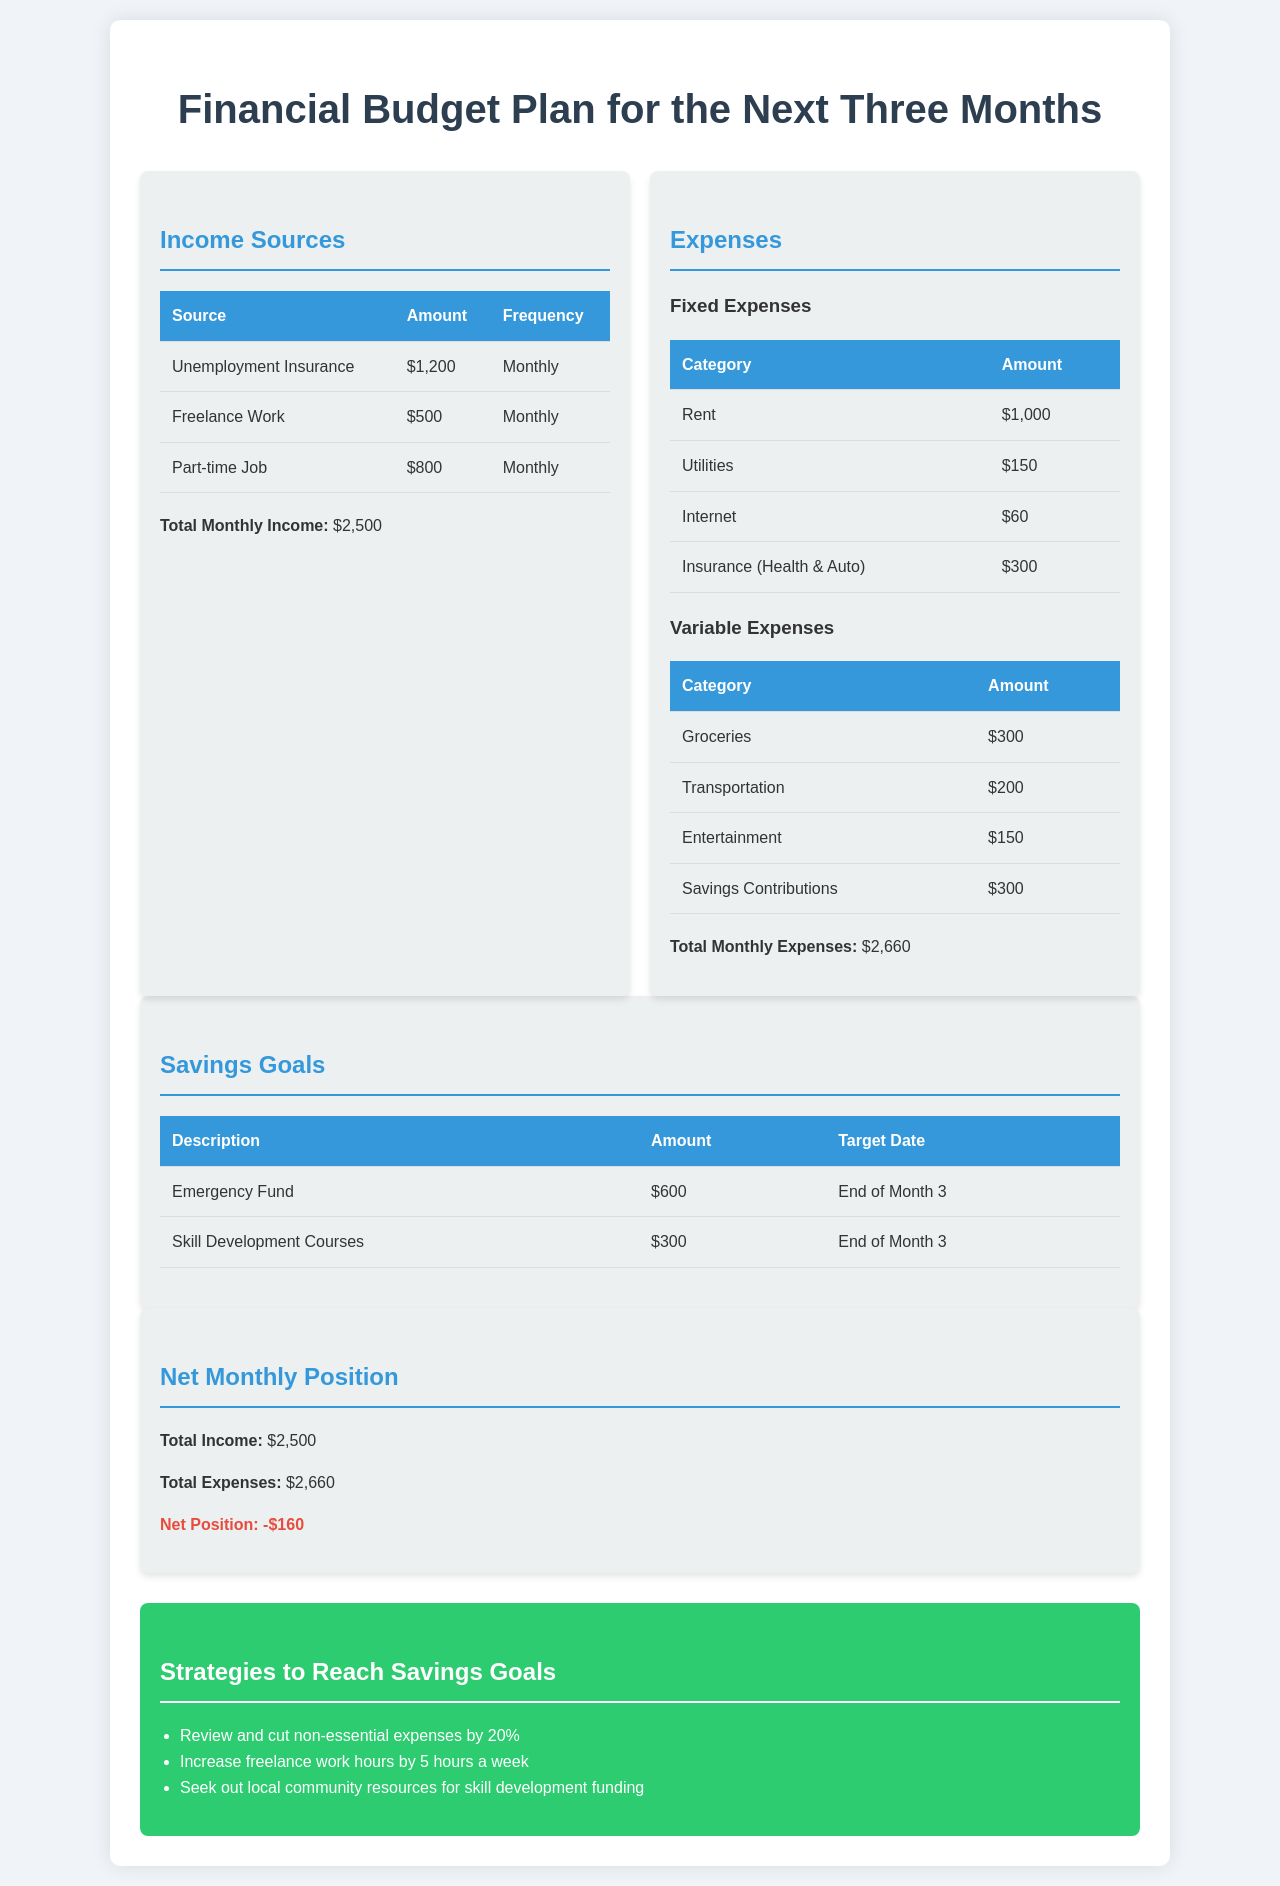What is the total monthly income? The total monthly income is provided at the end of the income sources section, which adds up to $2,500.
Answer: $2,500 What are the fixed expenses total? The document lists the fixed expenses and totals them at the end of that section, which is $1,000 + $150 + $60 + $300 = $1,510.
Answer: $1,510 How much is allocated for groceries? The expenses table specifically lists groceries as $300 under variable expenses.
Answer: $300 What is the net position monthly? The net position is calculated by subtracting total expenses from total income, resulting in -$160.
Answer: -$160 What are the savings goals? The document lists two savings goals, which are centered on creating an emergency fund and taking skill development courses.
Answer: Emergency Fund, Skill Development Courses When is the target date for the savings goals? The target dates for both savings goals are noted to be at the end of Month 3.
Answer: End of Month 3 What percentage of non-essential expenses is suggested to cut? The strategies section recommends to cut non-essential expenses by 20%.
Answer: 20% How much is the part-time job income? The income table specifies the part-time job income as $800 per month.
Answer: $800 What is the amount for transportation expenses? The transportation expenses under variable expenses are detailed as $200.
Answer: $200 How much should be contributed towards savings monthly? The document lists monthly savings contributions as $300 under the variable expenses section.
Answer: $300 